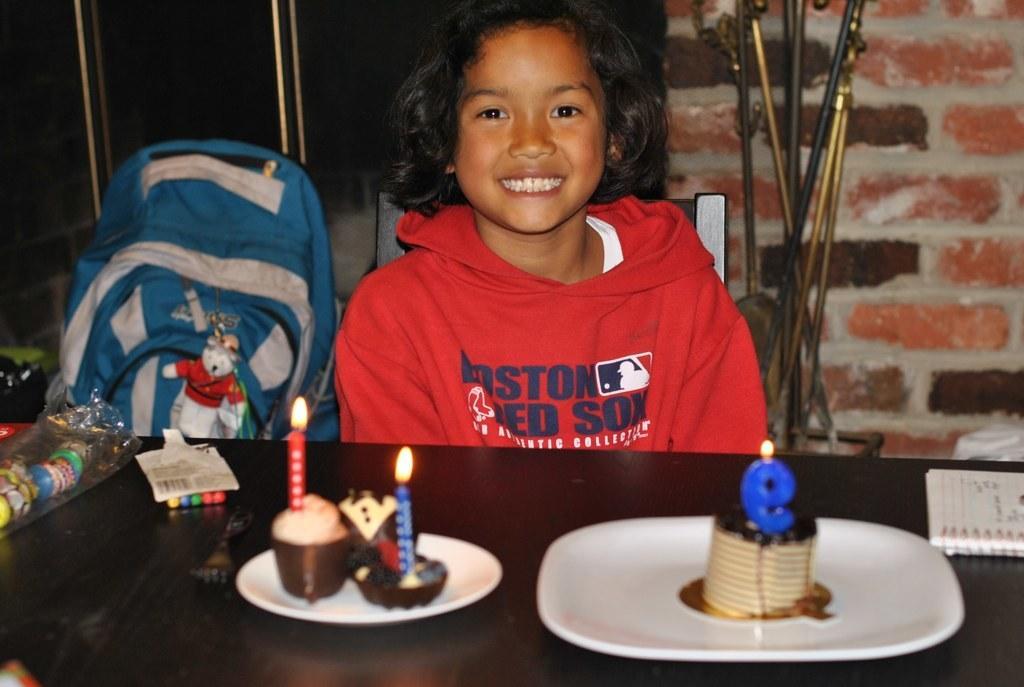Can you describe this image briefly? In this image i can see a girl sitting on a chair and smiling there is a cake in a plate there is a bag beside a girl at the back ground i can see a wall and a flower pot. 